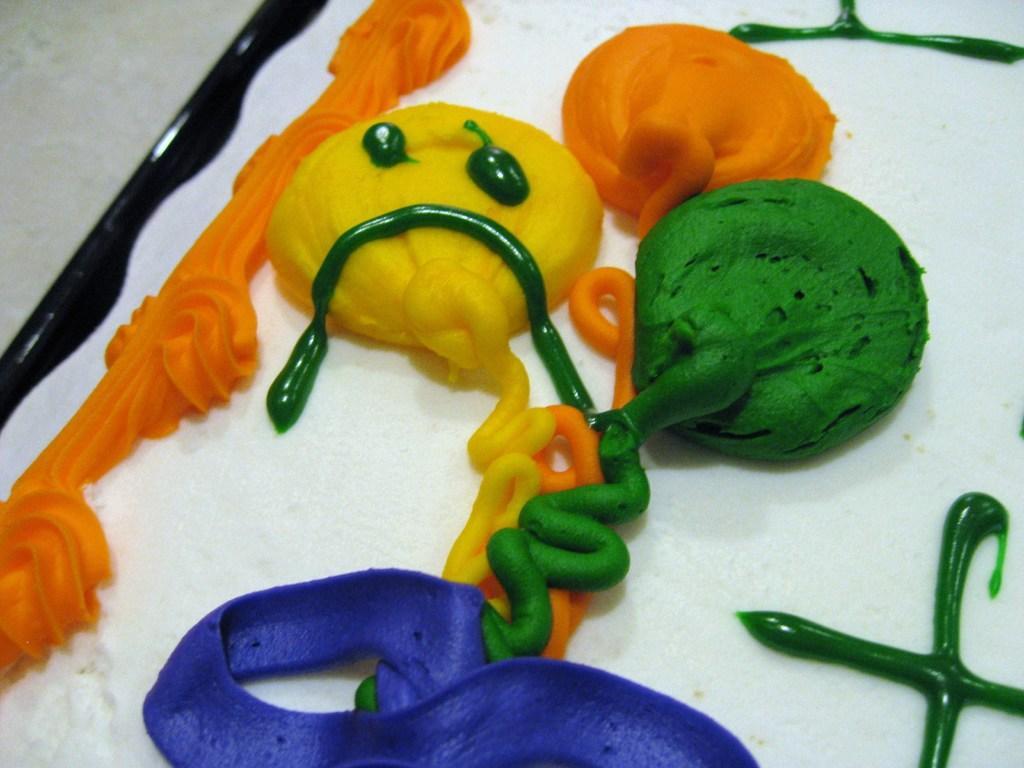Could you give a brief overview of what you see in this image? We can see colorful creams on the white surface. 